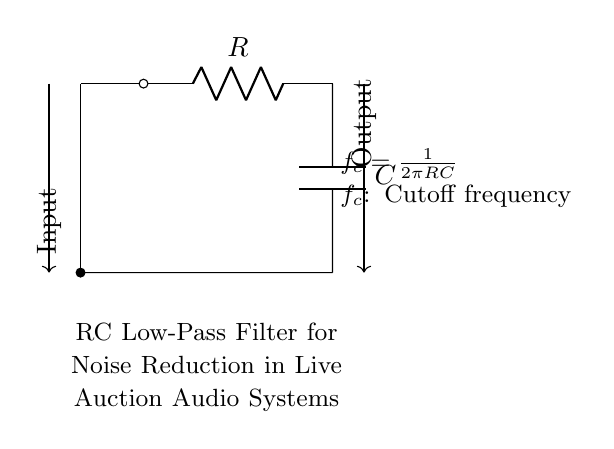What type of filter is this circuit? The circuit is designed as a low-pass filter, which allows signals with a frequency lower than a certain cutoff frequency to pass through while attenuating higher frequencies.
Answer: low-pass filter What are the main components of the circuit? The circuit consists of a resistor and a capacitor, which are the two main components used in this RC low-pass filter configuration.
Answer: resistor and capacitor What is the function of the capacitor? The capacitor stores and releases electrical energy and plays a key role in determining the cutoff frequency of the filter, affecting how signals are filtered based on their frequency.
Answer: stores and releases energy What is the cutoff frequency formula? The cutoff frequency can be calculated using the formula f_c = 1/(2πRC), which indicates how the resistor and capacitor values influence the frequency at which the filter begins to attenuate signals.
Answer: f_c = 1/(2πRC) How does changing the resistor value affect the circuit? Increasing the resistor value will lower the cutoff frequency, allowing fewer high-frequency signals to pass through, while decreasing the resistor will raise the cutoff frequency, allowing more high-frequency signals.
Answer: lowers or raises cutoff frequency What is the input shown in the circuit? The input in this circuit represents the audio signal that contains noise, which is to be filtered out by the RC low-pass filter before it reaches the output.
Answer: audio signal with noise What does the output represent? The output is the filtered audio signal after passing through the RC low-pass filter, which should have reduced noise and a clearer sound for live auction purposes.
Answer: filtered audio signal 